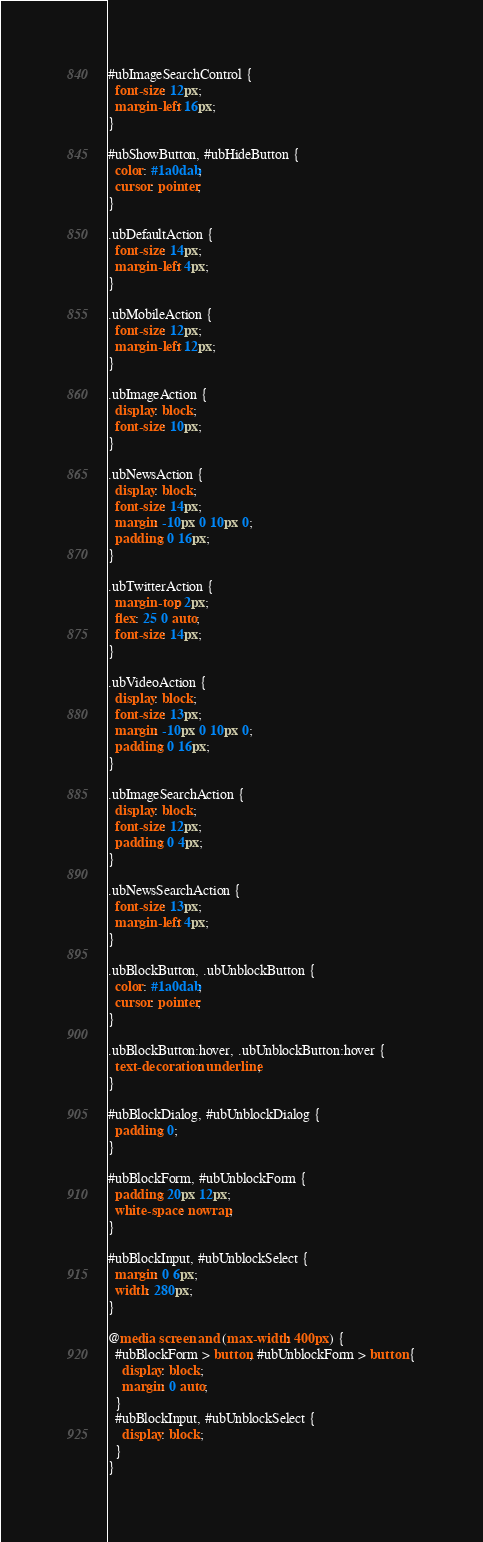Convert code to text. <code><loc_0><loc_0><loc_500><loc_500><_CSS_>#ubImageSearchControl {
  font-size: 12px;
  margin-left: 16px;
}

#ubShowButton, #ubHideButton {
  color: #1a0dab;
  cursor: pointer;
}

.ubDefaultAction {
  font-size: 14px;
  margin-left: 4px;
}

.ubMobileAction {
  font-size: 12px;
  margin-left: 12px;
}

.ubImageAction {
  display: block;
  font-size: 10px;
}

.ubNewsAction {
  display: block;
  font-size: 14px;
  margin: -10px 0 10px 0;
  padding: 0 16px;
}

.ubTwitterAction {
  margin-top: 2px;
  flex: 25 0 auto;
  font-size: 14px;
}

.ubVideoAction {
  display: block;
  font-size: 13px;
  margin: -10px 0 10px 0;
  padding: 0 16px;
}

.ubImageSearchAction {
  display: block;
  font-size: 12px;
  padding: 0 4px;
}

.ubNewsSearchAction {
  font-size: 13px;
  margin-left: 4px;
}

.ubBlockButton, .ubUnblockButton {
  color: #1a0dab;
  cursor: pointer;
}

.ubBlockButton:hover, .ubUnblockButton:hover {
  text-decoration: underline;
}

#ubBlockDialog, #ubUnblockDialog {
  padding: 0;
}

#ubBlockForm, #ubUnblockForm {
  padding: 20px 12px;
  white-space: nowrap;
}

#ubBlockInput, #ubUnblockSelect {
  margin: 0 6px;
  width: 280px;
}

@media screen and (max-width: 400px) {
  #ubBlockForm > button, #ubUnblockForm > button {
    display: block;
    margin: 0 auto;
  }
  #ubBlockInput, #ubUnblockSelect {
    display: block;
  }
}
</code> 